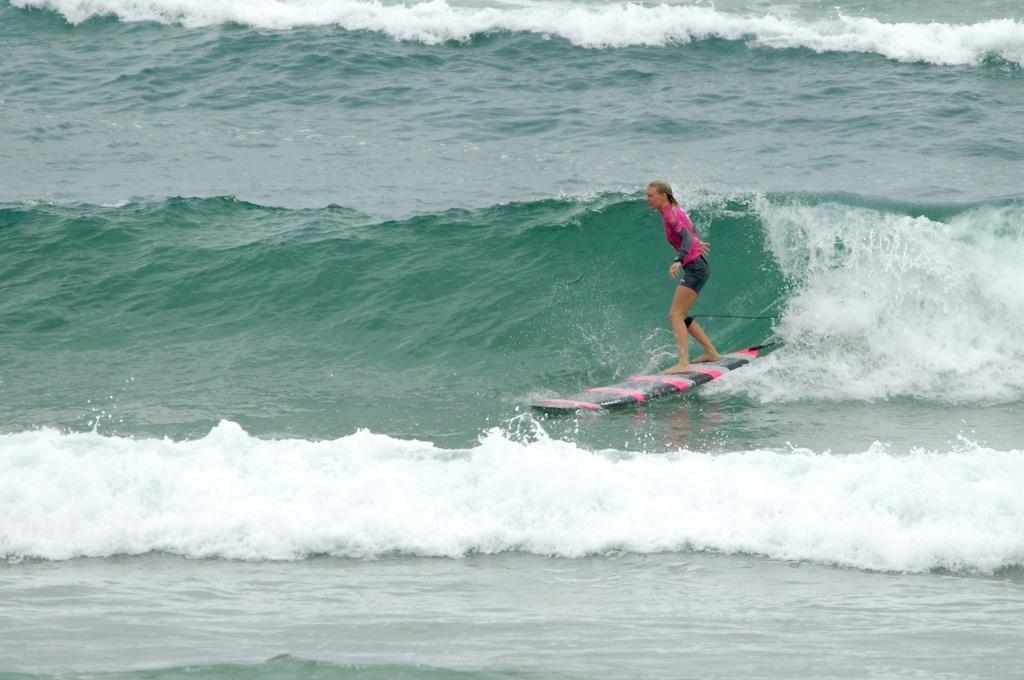How would you summarize this image in a sentence or two? In this image I can see a person surfing on the water. I can also see the water waves. 